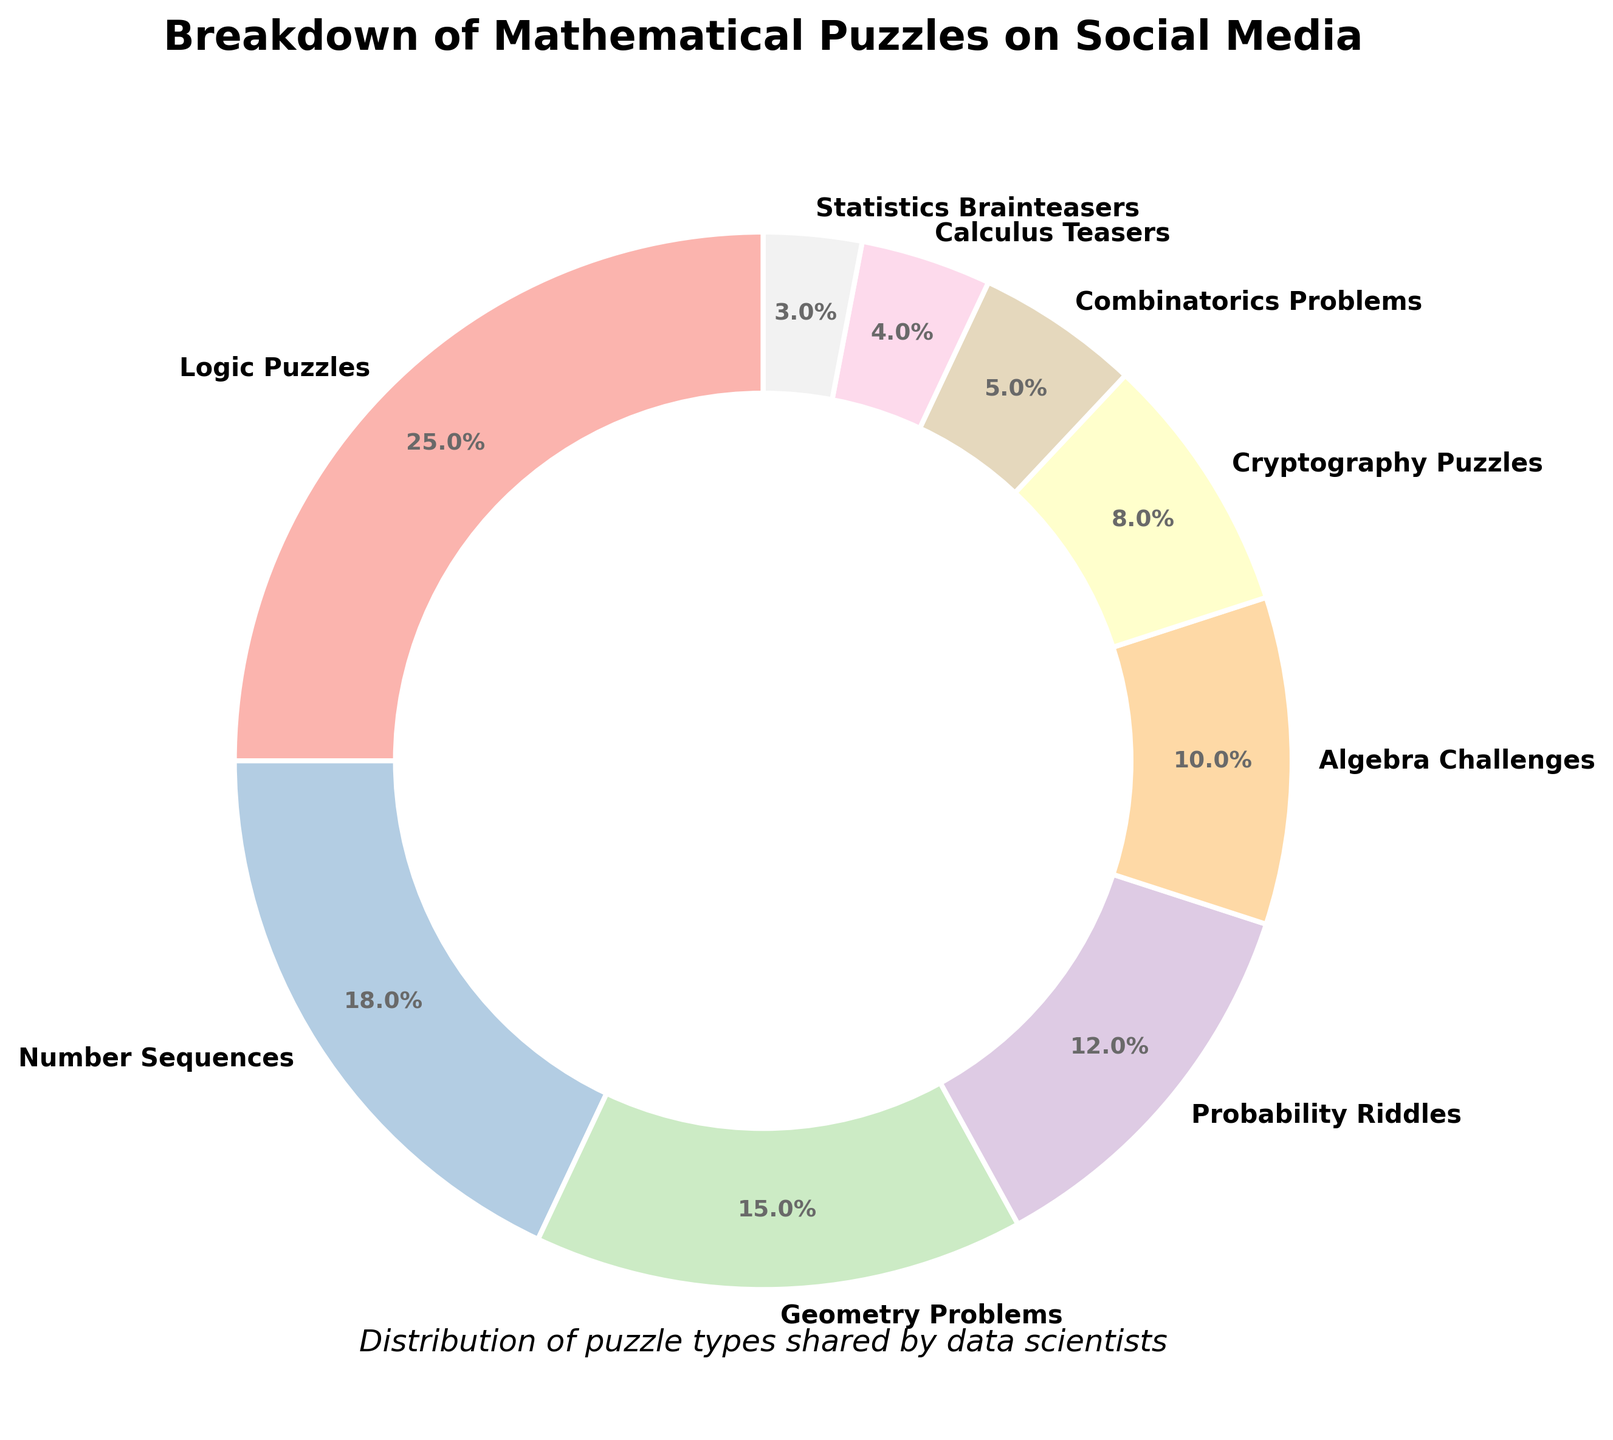What's the total percentage of Logic Puzzles and Number Sequences combined? Add the percentages of Logic Puzzles (25%) and Number Sequences (18%). 25 + 18 = 43
Answer: 43% Which type of puzzle has the smallest percentage distribution? Look at the pie chart to identify the segment with the smallest percentage. The segment for Statistics Brainteasers is the smallest at 3%.
Answer: Statistics Brainteasers Are Probability Riddles more popular than Geometry Problems? Compare the percentage of Probability Riddles (12%) to Geometry Problems (15%). 12 is less than 15, so Probability Riddles are not more popular than Geometry Problems.
Answer: No What is the difference in percentage between Algebra Challenges and Cryptography Puzzles? Subtract the percentage of Cryptography Puzzles (8%) from Algebra Challenges (10%). 10 - 8 = 2
Answer: 2% If the percentages of Combinatorics Problems and Calculus Teasers were combined into one category, what would be the new percentage for that category? Add the percentages of Combinatorics Problems (5%) and Calculus Teasers (4%). 5 + 4 = 9
Answer: 9% Which puzzle category has a percentage closest to 10%? Look for the category with a percentage nearest to 10%. Algebra Challenges are exactly at 10%.
Answer: Algebra Challenges Order the following types of puzzles from most to least shared: Statistics Brainteasers, Geometry Problems, and Number Sequences. Identify the percentages for each type: Statistics Brainteasers (3%), Geometry Problems (15%), Number Sequences (18%). Order them from highest to lowest: Number Sequences, Geometry Problems, Statistics Brainteasers.
Answer: Number Sequences, Geometry Problems, Statistics Brainteasers Is the percentage of Logic Puzzles more than twice the percentage of Probability Riddles? Double the percentage of Probability Riddles (12% * 2 = 24%), then compare it to Logic Puzzles (25%). 25% is more than 24%, so Logic Puzzles have a higher percentage.
Answer: Yes Which two puzzle categories have a combined percentage closest to Geometry Problems' percentage? Geometry Problems are at 15%. Check combinations: Algebra Challenges (10%) + Cryptography Puzzles (8%) = 18%; Combinatorics Problems (5%) + Calculus Teasers (4%) = 9%; Probability Riddles (12%) + Statistics Brainteasers (3%) = 15%. The closest combination is Probability Riddles and Statistics Brainteasers at 15%.
Answer: Probability Riddles and Statistics Brainteasers What is the average percentage of all puzzle types shown in the figure? Add all percentages: 25 + 18 + 15 + 12 + 10 + 8 + 5 + 4 + 3 = 100. There are 9 categories, so divide the total by 9. 100 / 9 ≈ 11.1
Answer: 11.1% 